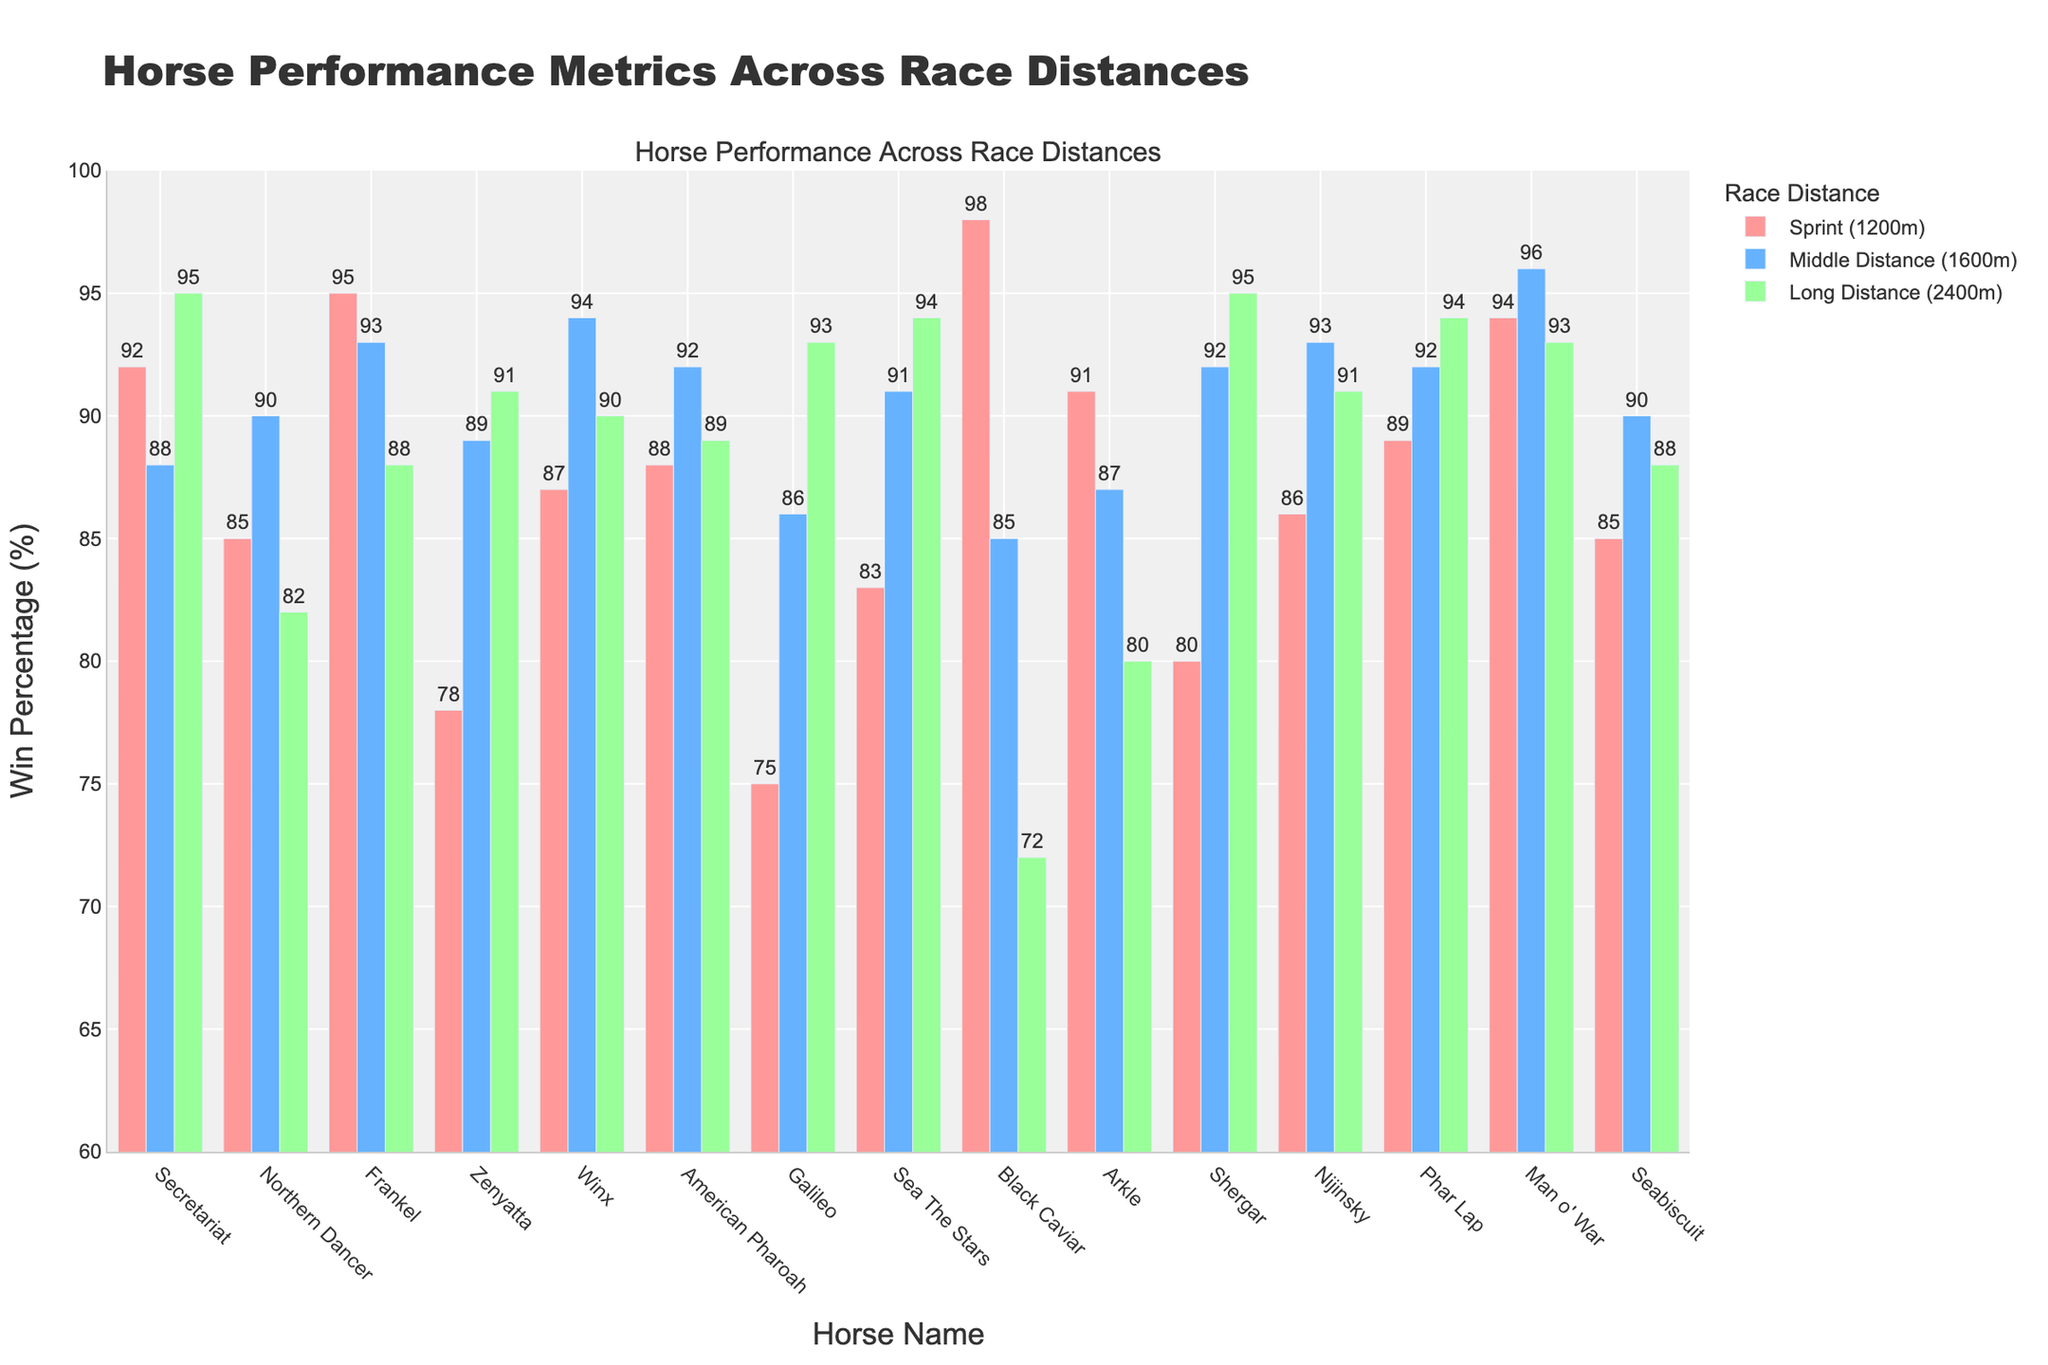Which horse has the highest win percentage in sprint races (1200m)? Look at each horse's sprint win percentage and identify the highest value.
Answer: Black Caviar Which horse has the lowest win percentage in long distance races (2400m)? Examine each horse's long distance win percentage to find and select the lowest value.
Answer: Black Caviar Between Secretariat and Northern Dancer, which horse performs better in middle distance races (1600m)? Compare the middle distance win percentages of Secretariat (88%) and Northern Dancer (90%).
Answer: Northern Dancer What is the average win percentage across all distances for Frankel? Add up Frankel's win percentages for each distance (95% + 93% + 88%) and divide by the number of distances (3).
Answer: 92% How much higher is Winx's middle distance win percentage compared to Zenyatta's middle distance win percentage? Subtract Zenyatta's middle distance win percentage (89%) from Winx's middle distance win percentage (94%).
Answer: 5% Which horse has the most consistent performance across all distances (i.e., smallest range of win percentages)? Calculate the range (difference between the highest and lowest win percentages) for each horse, and identify the smallest range. For Secretariat: 95% - 88% = 7%, Northern Dancer: 90% - 82% = 8%, Frankel: 95% - 88% = 7%, Zenyatta: 91% - 78% = 13%, Winx: 94% - 87% = 7%, American Pharoah: 92% - 88% = 4%, Galileo: 93% - 75% = 18%, Sea The Stars: 94% - 83% = 11%, Black Caviar: 98% - 72% = 26%, Arkle: 91% - 80% = 11%, Shergar: 95% - 80% = 15%, Nijinsky: 93% - 86% = 7%, Phar Lap: 94% - 89% = 5%, Man o' War: 96% - 93% = 3%, Seabiscuit: 90% - 85% = 5%.
Answer: Man o' War Is the win percentage for long distance races typically higher than for sprint races among all horses? Compare the win percentages across all horses for long distance and sprint races by summing up and calculating average win percentages for each distance. Sum for sprint: 92 + 85 + 95 + 78 + 87 + 88 + 75 + 83 + 98 + 91 + 80 + 86 + 89 + 94 + 85 = 1416, average sprint = 1416 / 15 = 94.4%. Sum for long distance: 95 + 82 + 88 + 91 + 90 + 89 + 93 + 94 + 72 + 80 + 95 + 91 + 94 + 93 + 88 = 1335, average long = 1335 / 15 = 89%.
Answer: No What is the combined win percentage in sprint and middle distance races for Sea The Stars? Add up Sea The Stars' win percentages for sprint (83%) and middle distance (91%).
Answer: 174% Which race distance does American Pharoah have the highest win percentage? Compare American Pharoah's win percentages in all three distances: sprint (88%), middle (92%), long (89%), and identify the highest one.
Answer: Middle Distance (1600m) 